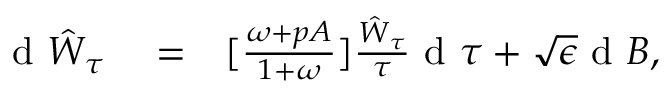<formula> <loc_0><loc_0><loc_500><loc_500>\begin{array} { r l r } { d \hat { W } _ { \tau } } & = } & { [ \frac { \omega + p A } { 1 + \omega } ] \frac { \hat { W } _ { \tau } } { \tau } d \tau + \sqrt { \epsilon } d B , } \end{array}</formula> 